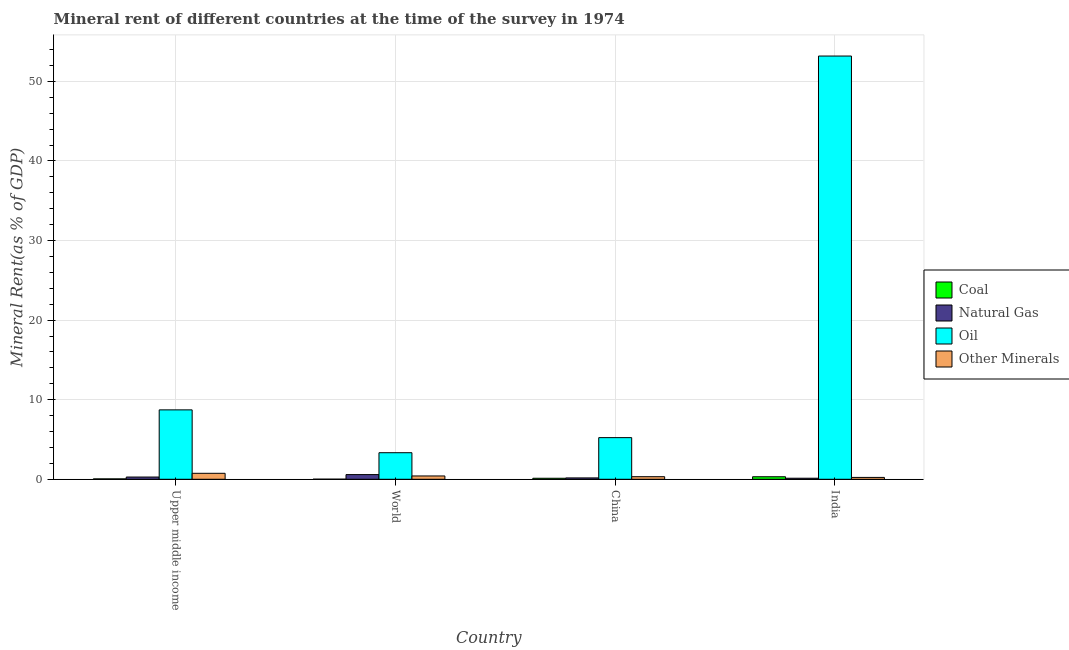How many different coloured bars are there?
Offer a very short reply. 4. How many groups of bars are there?
Make the answer very short. 4. How many bars are there on the 4th tick from the left?
Your response must be concise. 4. How many bars are there on the 4th tick from the right?
Your response must be concise. 4. In how many cases, is the number of bars for a given country not equal to the number of legend labels?
Your response must be concise. 0. What is the natural gas rent in China?
Keep it short and to the point. 0.17. Across all countries, what is the maximum  rent of other minerals?
Keep it short and to the point. 0.75. Across all countries, what is the minimum  rent of other minerals?
Offer a very short reply. 0.23. In which country was the oil rent maximum?
Your answer should be compact. India. In which country was the coal rent minimum?
Ensure brevity in your answer.  World. What is the total oil rent in the graph?
Your answer should be compact. 70.48. What is the difference between the  rent of other minerals in China and that in Upper middle income?
Provide a succinct answer. -0.43. What is the difference between the  rent of other minerals in China and the coal rent in India?
Offer a very short reply. 0.01. What is the average oil rent per country?
Make the answer very short. 17.62. What is the difference between the natural gas rent and  rent of other minerals in India?
Provide a short and direct response. -0.1. In how many countries, is the oil rent greater than 40 %?
Your answer should be compact. 1. What is the ratio of the natural gas rent in Upper middle income to that in World?
Keep it short and to the point. 0.48. Is the coal rent in China less than that in World?
Your answer should be compact. No. Is the difference between the coal rent in Upper middle income and World greater than the difference between the oil rent in Upper middle income and World?
Provide a short and direct response. No. What is the difference between the highest and the second highest coal rent?
Your response must be concise. 0.19. What is the difference between the highest and the lowest  rent of other minerals?
Provide a succinct answer. 0.52. In how many countries, is the oil rent greater than the average oil rent taken over all countries?
Provide a short and direct response. 1. Is the sum of the oil rent in Upper middle income and World greater than the maximum coal rent across all countries?
Make the answer very short. Yes. Is it the case that in every country, the sum of the natural gas rent and oil rent is greater than the sum of coal rent and  rent of other minerals?
Make the answer very short. No. What does the 3rd bar from the left in India represents?
Your answer should be very brief. Oil. What does the 4th bar from the right in India represents?
Give a very brief answer. Coal. Is it the case that in every country, the sum of the coal rent and natural gas rent is greater than the oil rent?
Your answer should be very brief. No. Are all the bars in the graph horizontal?
Give a very brief answer. No. What is the difference between two consecutive major ticks on the Y-axis?
Offer a very short reply. 10. Are the values on the major ticks of Y-axis written in scientific E-notation?
Offer a terse response. No. Does the graph contain grids?
Ensure brevity in your answer.  Yes. How many legend labels are there?
Provide a succinct answer. 4. How are the legend labels stacked?
Offer a very short reply. Vertical. What is the title of the graph?
Ensure brevity in your answer.  Mineral rent of different countries at the time of the survey in 1974. What is the label or title of the Y-axis?
Give a very brief answer. Mineral Rent(as % of GDP). What is the Mineral Rent(as % of GDP) of Coal in Upper middle income?
Ensure brevity in your answer.  0.05. What is the Mineral Rent(as % of GDP) in Natural Gas in Upper middle income?
Give a very brief answer. 0.28. What is the Mineral Rent(as % of GDP) of Oil in Upper middle income?
Your response must be concise. 8.72. What is the Mineral Rent(as % of GDP) in Other Minerals in Upper middle income?
Your response must be concise. 0.75. What is the Mineral Rent(as % of GDP) of Coal in World?
Give a very brief answer. 0.01. What is the Mineral Rent(as % of GDP) of Natural Gas in World?
Offer a terse response. 0.59. What is the Mineral Rent(as % of GDP) in Oil in World?
Your answer should be compact. 3.34. What is the Mineral Rent(as % of GDP) in Other Minerals in World?
Ensure brevity in your answer.  0.42. What is the Mineral Rent(as % of GDP) in Coal in China?
Your response must be concise. 0.13. What is the Mineral Rent(as % of GDP) of Natural Gas in China?
Keep it short and to the point. 0.17. What is the Mineral Rent(as % of GDP) in Oil in China?
Your answer should be compact. 5.23. What is the Mineral Rent(as % of GDP) of Other Minerals in China?
Your response must be concise. 0.32. What is the Mineral Rent(as % of GDP) in Coal in India?
Give a very brief answer. 0.32. What is the Mineral Rent(as % of GDP) in Natural Gas in India?
Keep it short and to the point. 0.13. What is the Mineral Rent(as % of GDP) of Oil in India?
Offer a very short reply. 53.18. What is the Mineral Rent(as % of GDP) in Other Minerals in India?
Your answer should be compact. 0.23. Across all countries, what is the maximum Mineral Rent(as % of GDP) of Coal?
Offer a terse response. 0.32. Across all countries, what is the maximum Mineral Rent(as % of GDP) in Natural Gas?
Keep it short and to the point. 0.59. Across all countries, what is the maximum Mineral Rent(as % of GDP) in Oil?
Offer a very short reply. 53.18. Across all countries, what is the maximum Mineral Rent(as % of GDP) in Other Minerals?
Your answer should be very brief. 0.75. Across all countries, what is the minimum Mineral Rent(as % of GDP) in Coal?
Your response must be concise. 0.01. Across all countries, what is the minimum Mineral Rent(as % of GDP) of Natural Gas?
Your answer should be compact. 0.13. Across all countries, what is the minimum Mineral Rent(as % of GDP) of Oil?
Your answer should be compact. 3.34. Across all countries, what is the minimum Mineral Rent(as % of GDP) of Other Minerals?
Offer a very short reply. 0.23. What is the total Mineral Rent(as % of GDP) of Coal in the graph?
Give a very brief answer. 0.51. What is the total Mineral Rent(as % of GDP) in Natural Gas in the graph?
Give a very brief answer. 1.17. What is the total Mineral Rent(as % of GDP) of Oil in the graph?
Make the answer very short. 70.48. What is the total Mineral Rent(as % of GDP) in Other Minerals in the graph?
Give a very brief answer. 1.73. What is the difference between the Mineral Rent(as % of GDP) in Coal in Upper middle income and that in World?
Your answer should be very brief. 0.04. What is the difference between the Mineral Rent(as % of GDP) in Natural Gas in Upper middle income and that in World?
Your answer should be compact. -0.31. What is the difference between the Mineral Rent(as % of GDP) of Oil in Upper middle income and that in World?
Offer a terse response. 5.38. What is the difference between the Mineral Rent(as % of GDP) of Other Minerals in Upper middle income and that in World?
Your response must be concise. 0.33. What is the difference between the Mineral Rent(as % of GDP) of Coal in Upper middle income and that in China?
Ensure brevity in your answer.  -0.08. What is the difference between the Mineral Rent(as % of GDP) of Natural Gas in Upper middle income and that in China?
Give a very brief answer. 0.11. What is the difference between the Mineral Rent(as % of GDP) of Oil in Upper middle income and that in China?
Give a very brief answer. 3.49. What is the difference between the Mineral Rent(as % of GDP) in Other Minerals in Upper middle income and that in China?
Give a very brief answer. 0.43. What is the difference between the Mineral Rent(as % of GDP) of Coal in Upper middle income and that in India?
Your answer should be compact. -0.27. What is the difference between the Mineral Rent(as % of GDP) of Natural Gas in Upper middle income and that in India?
Ensure brevity in your answer.  0.15. What is the difference between the Mineral Rent(as % of GDP) of Oil in Upper middle income and that in India?
Provide a succinct answer. -44.46. What is the difference between the Mineral Rent(as % of GDP) of Other Minerals in Upper middle income and that in India?
Your response must be concise. 0.52. What is the difference between the Mineral Rent(as % of GDP) in Coal in World and that in China?
Offer a very short reply. -0.12. What is the difference between the Mineral Rent(as % of GDP) in Natural Gas in World and that in China?
Your response must be concise. 0.42. What is the difference between the Mineral Rent(as % of GDP) in Oil in World and that in China?
Provide a succinct answer. -1.9. What is the difference between the Mineral Rent(as % of GDP) in Other Minerals in World and that in China?
Provide a succinct answer. 0.09. What is the difference between the Mineral Rent(as % of GDP) in Coal in World and that in India?
Offer a terse response. -0.31. What is the difference between the Mineral Rent(as % of GDP) of Natural Gas in World and that in India?
Offer a terse response. 0.46. What is the difference between the Mineral Rent(as % of GDP) in Oil in World and that in India?
Ensure brevity in your answer.  -49.85. What is the difference between the Mineral Rent(as % of GDP) of Other Minerals in World and that in India?
Provide a succinct answer. 0.18. What is the difference between the Mineral Rent(as % of GDP) of Coal in China and that in India?
Offer a very short reply. -0.19. What is the difference between the Mineral Rent(as % of GDP) in Natural Gas in China and that in India?
Your response must be concise. 0.04. What is the difference between the Mineral Rent(as % of GDP) of Oil in China and that in India?
Provide a short and direct response. -47.95. What is the difference between the Mineral Rent(as % of GDP) of Other Minerals in China and that in India?
Give a very brief answer. 0.09. What is the difference between the Mineral Rent(as % of GDP) of Coal in Upper middle income and the Mineral Rent(as % of GDP) of Natural Gas in World?
Give a very brief answer. -0.54. What is the difference between the Mineral Rent(as % of GDP) of Coal in Upper middle income and the Mineral Rent(as % of GDP) of Oil in World?
Make the answer very short. -3.29. What is the difference between the Mineral Rent(as % of GDP) of Coal in Upper middle income and the Mineral Rent(as % of GDP) of Other Minerals in World?
Provide a succinct answer. -0.37. What is the difference between the Mineral Rent(as % of GDP) in Natural Gas in Upper middle income and the Mineral Rent(as % of GDP) in Oil in World?
Provide a succinct answer. -3.06. What is the difference between the Mineral Rent(as % of GDP) in Natural Gas in Upper middle income and the Mineral Rent(as % of GDP) in Other Minerals in World?
Make the answer very short. -0.14. What is the difference between the Mineral Rent(as % of GDP) in Oil in Upper middle income and the Mineral Rent(as % of GDP) in Other Minerals in World?
Make the answer very short. 8.3. What is the difference between the Mineral Rent(as % of GDP) of Coal in Upper middle income and the Mineral Rent(as % of GDP) of Natural Gas in China?
Provide a short and direct response. -0.12. What is the difference between the Mineral Rent(as % of GDP) of Coal in Upper middle income and the Mineral Rent(as % of GDP) of Oil in China?
Your response must be concise. -5.18. What is the difference between the Mineral Rent(as % of GDP) in Coal in Upper middle income and the Mineral Rent(as % of GDP) in Other Minerals in China?
Give a very brief answer. -0.27. What is the difference between the Mineral Rent(as % of GDP) of Natural Gas in Upper middle income and the Mineral Rent(as % of GDP) of Oil in China?
Make the answer very short. -4.95. What is the difference between the Mineral Rent(as % of GDP) in Natural Gas in Upper middle income and the Mineral Rent(as % of GDP) in Other Minerals in China?
Keep it short and to the point. -0.04. What is the difference between the Mineral Rent(as % of GDP) of Oil in Upper middle income and the Mineral Rent(as % of GDP) of Other Minerals in China?
Give a very brief answer. 8.4. What is the difference between the Mineral Rent(as % of GDP) of Coal in Upper middle income and the Mineral Rent(as % of GDP) of Natural Gas in India?
Ensure brevity in your answer.  -0.08. What is the difference between the Mineral Rent(as % of GDP) of Coal in Upper middle income and the Mineral Rent(as % of GDP) of Oil in India?
Keep it short and to the point. -53.13. What is the difference between the Mineral Rent(as % of GDP) in Coal in Upper middle income and the Mineral Rent(as % of GDP) in Other Minerals in India?
Offer a terse response. -0.18. What is the difference between the Mineral Rent(as % of GDP) of Natural Gas in Upper middle income and the Mineral Rent(as % of GDP) of Oil in India?
Make the answer very short. -52.9. What is the difference between the Mineral Rent(as % of GDP) in Natural Gas in Upper middle income and the Mineral Rent(as % of GDP) in Other Minerals in India?
Your answer should be compact. 0.05. What is the difference between the Mineral Rent(as % of GDP) in Oil in Upper middle income and the Mineral Rent(as % of GDP) in Other Minerals in India?
Your answer should be very brief. 8.49. What is the difference between the Mineral Rent(as % of GDP) in Coal in World and the Mineral Rent(as % of GDP) in Natural Gas in China?
Ensure brevity in your answer.  -0.16. What is the difference between the Mineral Rent(as % of GDP) of Coal in World and the Mineral Rent(as % of GDP) of Oil in China?
Give a very brief answer. -5.22. What is the difference between the Mineral Rent(as % of GDP) of Coal in World and the Mineral Rent(as % of GDP) of Other Minerals in China?
Ensure brevity in your answer.  -0.31. What is the difference between the Mineral Rent(as % of GDP) in Natural Gas in World and the Mineral Rent(as % of GDP) in Oil in China?
Ensure brevity in your answer.  -4.64. What is the difference between the Mineral Rent(as % of GDP) in Natural Gas in World and the Mineral Rent(as % of GDP) in Other Minerals in China?
Give a very brief answer. 0.27. What is the difference between the Mineral Rent(as % of GDP) of Oil in World and the Mineral Rent(as % of GDP) of Other Minerals in China?
Offer a very short reply. 3.01. What is the difference between the Mineral Rent(as % of GDP) of Coal in World and the Mineral Rent(as % of GDP) of Natural Gas in India?
Keep it short and to the point. -0.12. What is the difference between the Mineral Rent(as % of GDP) of Coal in World and the Mineral Rent(as % of GDP) of Oil in India?
Ensure brevity in your answer.  -53.17. What is the difference between the Mineral Rent(as % of GDP) of Coal in World and the Mineral Rent(as % of GDP) of Other Minerals in India?
Your answer should be compact. -0.22. What is the difference between the Mineral Rent(as % of GDP) of Natural Gas in World and the Mineral Rent(as % of GDP) of Oil in India?
Keep it short and to the point. -52.59. What is the difference between the Mineral Rent(as % of GDP) in Natural Gas in World and the Mineral Rent(as % of GDP) in Other Minerals in India?
Your answer should be very brief. 0.36. What is the difference between the Mineral Rent(as % of GDP) of Oil in World and the Mineral Rent(as % of GDP) of Other Minerals in India?
Ensure brevity in your answer.  3.1. What is the difference between the Mineral Rent(as % of GDP) of Coal in China and the Mineral Rent(as % of GDP) of Natural Gas in India?
Your response must be concise. -0. What is the difference between the Mineral Rent(as % of GDP) of Coal in China and the Mineral Rent(as % of GDP) of Oil in India?
Give a very brief answer. -53.06. What is the difference between the Mineral Rent(as % of GDP) in Coal in China and the Mineral Rent(as % of GDP) in Other Minerals in India?
Your answer should be very brief. -0.11. What is the difference between the Mineral Rent(as % of GDP) of Natural Gas in China and the Mineral Rent(as % of GDP) of Oil in India?
Offer a terse response. -53.01. What is the difference between the Mineral Rent(as % of GDP) of Natural Gas in China and the Mineral Rent(as % of GDP) of Other Minerals in India?
Your answer should be compact. -0.06. What is the difference between the Mineral Rent(as % of GDP) in Oil in China and the Mineral Rent(as % of GDP) in Other Minerals in India?
Provide a short and direct response. 5. What is the average Mineral Rent(as % of GDP) in Coal per country?
Your answer should be very brief. 0.13. What is the average Mineral Rent(as % of GDP) of Natural Gas per country?
Your answer should be very brief. 0.29. What is the average Mineral Rent(as % of GDP) of Oil per country?
Make the answer very short. 17.62. What is the average Mineral Rent(as % of GDP) of Other Minerals per country?
Make the answer very short. 0.43. What is the difference between the Mineral Rent(as % of GDP) of Coal and Mineral Rent(as % of GDP) of Natural Gas in Upper middle income?
Give a very brief answer. -0.23. What is the difference between the Mineral Rent(as % of GDP) in Coal and Mineral Rent(as % of GDP) in Oil in Upper middle income?
Offer a terse response. -8.67. What is the difference between the Mineral Rent(as % of GDP) of Coal and Mineral Rent(as % of GDP) of Other Minerals in Upper middle income?
Offer a very short reply. -0.7. What is the difference between the Mineral Rent(as % of GDP) in Natural Gas and Mineral Rent(as % of GDP) in Oil in Upper middle income?
Provide a short and direct response. -8.44. What is the difference between the Mineral Rent(as % of GDP) of Natural Gas and Mineral Rent(as % of GDP) of Other Minerals in Upper middle income?
Offer a terse response. -0.47. What is the difference between the Mineral Rent(as % of GDP) in Oil and Mineral Rent(as % of GDP) in Other Minerals in Upper middle income?
Offer a very short reply. 7.97. What is the difference between the Mineral Rent(as % of GDP) of Coal and Mineral Rent(as % of GDP) of Natural Gas in World?
Provide a succinct answer. -0.58. What is the difference between the Mineral Rent(as % of GDP) of Coal and Mineral Rent(as % of GDP) of Oil in World?
Make the answer very short. -3.32. What is the difference between the Mineral Rent(as % of GDP) of Coal and Mineral Rent(as % of GDP) of Other Minerals in World?
Provide a succinct answer. -0.4. What is the difference between the Mineral Rent(as % of GDP) of Natural Gas and Mineral Rent(as % of GDP) of Oil in World?
Offer a very short reply. -2.75. What is the difference between the Mineral Rent(as % of GDP) of Natural Gas and Mineral Rent(as % of GDP) of Other Minerals in World?
Your answer should be compact. 0.17. What is the difference between the Mineral Rent(as % of GDP) in Oil and Mineral Rent(as % of GDP) in Other Minerals in World?
Your answer should be very brief. 2.92. What is the difference between the Mineral Rent(as % of GDP) in Coal and Mineral Rent(as % of GDP) in Natural Gas in China?
Your response must be concise. -0.04. What is the difference between the Mineral Rent(as % of GDP) in Coal and Mineral Rent(as % of GDP) in Oil in China?
Provide a short and direct response. -5.11. What is the difference between the Mineral Rent(as % of GDP) of Coal and Mineral Rent(as % of GDP) of Other Minerals in China?
Offer a very short reply. -0.2. What is the difference between the Mineral Rent(as % of GDP) of Natural Gas and Mineral Rent(as % of GDP) of Oil in China?
Your answer should be compact. -5.06. What is the difference between the Mineral Rent(as % of GDP) of Natural Gas and Mineral Rent(as % of GDP) of Other Minerals in China?
Ensure brevity in your answer.  -0.15. What is the difference between the Mineral Rent(as % of GDP) of Oil and Mineral Rent(as % of GDP) of Other Minerals in China?
Your answer should be very brief. 4.91. What is the difference between the Mineral Rent(as % of GDP) of Coal and Mineral Rent(as % of GDP) of Natural Gas in India?
Ensure brevity in your answer.  0.19. What is the difference between the Mineral Rent(as % of GDP) in Coal and Mineral Rent(as % of GDP) in Oil in India?
Provide a succinct answer. -52.87. What is the difference between the Mineral Rent(as % of GDP) of Coal and Mineral Rent(as % of GDP) of Other Minerals in India?
Provide a short and direct response. 0.08. What is the difference between the Mineral Rent(as % of GDP) of Natural Gas and Mineral Rent(as % of GDP) of Oil in India?
Offer a terse response. -53.05. What is the difference between the Mineral Rent(as % of GDP) in Natural Gas and Mineral Rent(as % of GDP) in Other Minerals in India?
Give a very brief answer. -0.1. What is the difference between the Mineral Rent(as % of GDP) of Oil and Mineral Rent(as % of GDP) of Other Minerals in India?
Offer a terse response. 52.95. What is the ratio of the Mineral Rent(as % of GDP) of Coal in Upper middle income to that in World?
Your answer should be very brief. 4.04. What is the ratio of the Mineral Rent(as % of GDP) of Natural Gas in Upper middle income to that in World?
Provide a succinct answer. 0.48. What is the ratio of the Mineral Rent(as % of GDP) in Oil in Upper middle income to that in World?
Provide a succinct answer. 2.61. What is the ratio of the Mineral Rent(as % of GDP) in Other Minerals in Upper middle income to that in World?
Provide a succinct answer. 1.8. What is the ratio of the Mineral Rent(as % of GDP) in Coal in Upper middle income to that in China?
Your answer should be compact. 0.38. What is the ratio of the Mineral Rent(as % of GDP) of Natural Gas in Upper middle income to that in China?
Keep it short and to the point. 1.64. What is the ratio of the Mineral Rent(as % of GDP) in Oil in Upper middle income to that in China?
Provide a succinct answer. 1.67. What is the ratio of the Mineral Rent(as % of GDP) of Other Minerals in Upper middle income to that in China?
Ensure brevity in your answer.  2.32. What is the ratio of the Mineral Rent(as % of GDP) in Coal in Upper middle income to that in India?
Provide a succinct answer. 0.16. What is the ratio of the Mineral Rent(as % of GDP) in Natural Gas in Upper middle income to that in India?
Make the answer very short. 2.13. What is the ratio of the Mineral Rent(as % of GDP) of Oil in Upper middle income to that in India?
Your answer should be compact. 0.16. What is the ratio of the Mineral Rent(as % of GDP) in Other Minerals in Upper middle income to that in India?
Give a very brief answer. 3.21. What is the ratio of the Mineral Rent(as % of GDP) in Coal in World to that in China?
Your response must be concise. 0.1. What is the ratio of the Mineral Rent(as % of GDP) in Natural Gas in World to that in China?
Your answer should be compact. 3.44. What is the ratio of the Mineral Rent(as % of GDP) of Oil in World to that in China?
Keep it short and to the point. 0.64. What is the ratio of the Mineral Rent(as % of GDP) in Other Minerals in World to that in China?
Ensure brevity in your answer.  1.29. What is the ratio of the Mineral Rent(as % of GDP) in Coal in World to that in India?
Ensure brevity in your answer.  0.04. What is the ratio of the Mineral Rent(as % of GDP) in Natural Gas in World to that in India?
Your answer should be compact. 4.46. What is the ratio of the Mineral Rent(as % of GDP) of Oil in World to that in India?
Provide a short and direct response. 0.06. What is the ratio of the Mineral Rent(as % of GDP) in Other Minerals in World to that in India?
Your answer should be compact. 1.78. What is the ratio of the Mineral Rent(as % of GDP) in Coal in China to that in India?
Provide a short and direct response. 0.4. What is the ratio of the Mineral Rent(as % of GDP) in Natural Gas in China to that in India?
Your answer should be very brief. 1.3. What is the ratio of the Mineral Rent(as % of GDP) in Oil in China to that in India?
Your answer should be very brief. 0.1. What is the ratio of the Mineral Rent(as % of GDP) of Other Minerals in China to that in India?
Provide a succinct answer. 1.38. What is the difference between the highest and the second highest Mineral Rent(as % of GDP) in Coal?
Give a very brief answer. 0.19. What is the difference between the highest and the second highest Mineral Rent(as % of GDP) of Natural Gas?
Offer a very short reply. 0.31. What is the difference between the highest and the second highest Mineral Rent(as % of GDP) of Oil?
Your answer should be compact. 44.46. What is the difference between the highest and the second highest Mineral Rent(as % of GDP) of Other Minerals?
Your answer should be very brief. 0.33. What is the difference between the highest and the lowest Mineral Rent(as % of GDP) of Coal?
Offer a terse response. 0.31. What is the difference between the highest and the lowest Mineral Rent(as % of GDP) of Natural Gas?
Provide a succinct answer. 0.46. What is the difference between the highest and the lowest Mineral Rent(as % of GDP) of Oil?
Provide a short and direct response. 49.85. What is the difference between the highest and the lowest Mineral Rent(as % of GDP) in Other Minerals?
Offer a terse response. 0.52. 